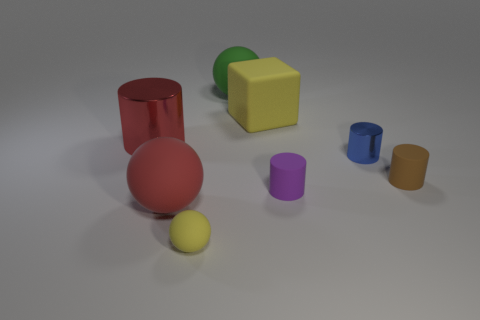How big is the thing that is left of the small yellow rubber object and behind the red rubber thing?
Provide a short and direct response. Large. Are there more blue cylinders on the left side of the purple rubber cylinder than tiny rubber cylinders in front of the red metal cylinder?
Offer a very short reply. No. What is the color of the big metal object that is the same shape as the small blue object?
Make the answer very short. Red. There is a large matte ball that is behind the large yellow rubber object; is it the same color as the big shiny cylinder?
Provide a short and direct response. No. How many small yellow balls are there?
Your answer should be very brief. 1. Are the yellow object that is on the right side of the large green rubber ball and the purple cylinder made of the same material?
Provide a succinct answer. Yes. Is there any other thing that is made of the same material as the big yellow thing?
Offer a terse response. Yes. There is a metallic thing that is to the left of the large matte ball that is behind the matte cube; what number of small brown cylinders are behind it?
Make the answer very short. 0. What size is the yellow matte cube?
Offer a very short reply. Large. Do the cube and the small shiny cylinder have the same color?
Provide a short and direct response. No. 